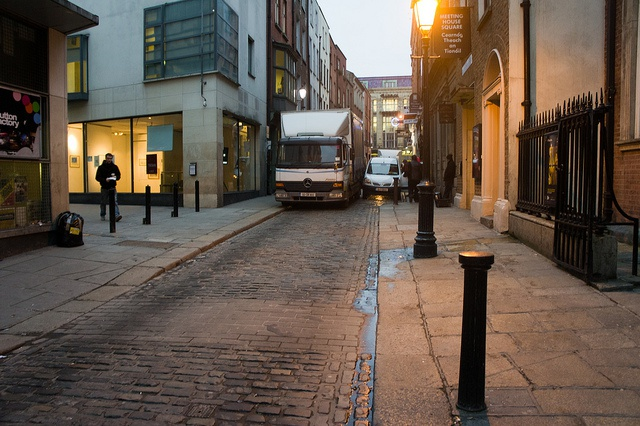Describe the objects in this image and their specific colors. I can see truck in black, gray, lightgray, and darkgray tones, truck in black, darkgray, lightgray, and gray tones, backpack in black, gray, olive, and maroon tones, people in black, gray, maroon, and olive tones, and people in black, maroon, and gray tones in this image. 